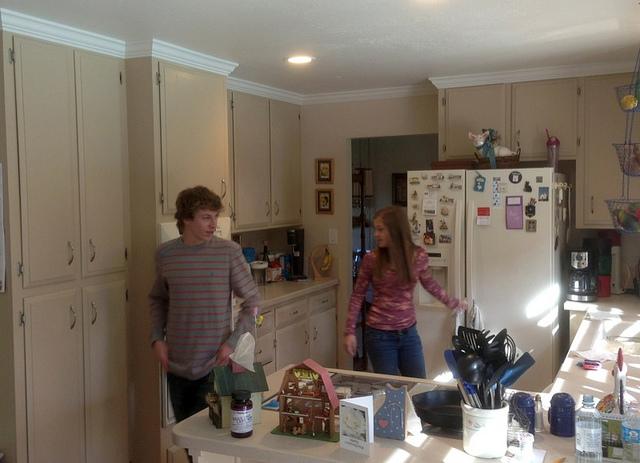How many people live here?
Quick response, please. 2. What is the man doing?
Give a very brief answer. Standing. Is it a man or a woman standing in the kitchen?
Quick response, please. Both. What are the kitchen utensils doing?
Write a very short answer. Stored in container. What color is the man's sweater?
Concise answer only. Gray and red. Are the people seated?
Write a very short answer. No. What is the condiment in the lower right corner?
Be succinct. Water. Are these people cooking?
Concise answer only. No. What is on top of the refrigerator?
Give a very brief answer. Pig. Is this a present day photo?
Answer briefly. Yes. Do they have enough storage in this room?
Concise answer only. Yes. What room is pictured?
Give a very brief answer. Kitchen. How many men are in the kitchen?
Be succinct. 1. How many people are shown?
Concise answer only. 2. Are the lights on?
Be succinct. Yes. How many lights are there?
Write a very short answer. 1. 